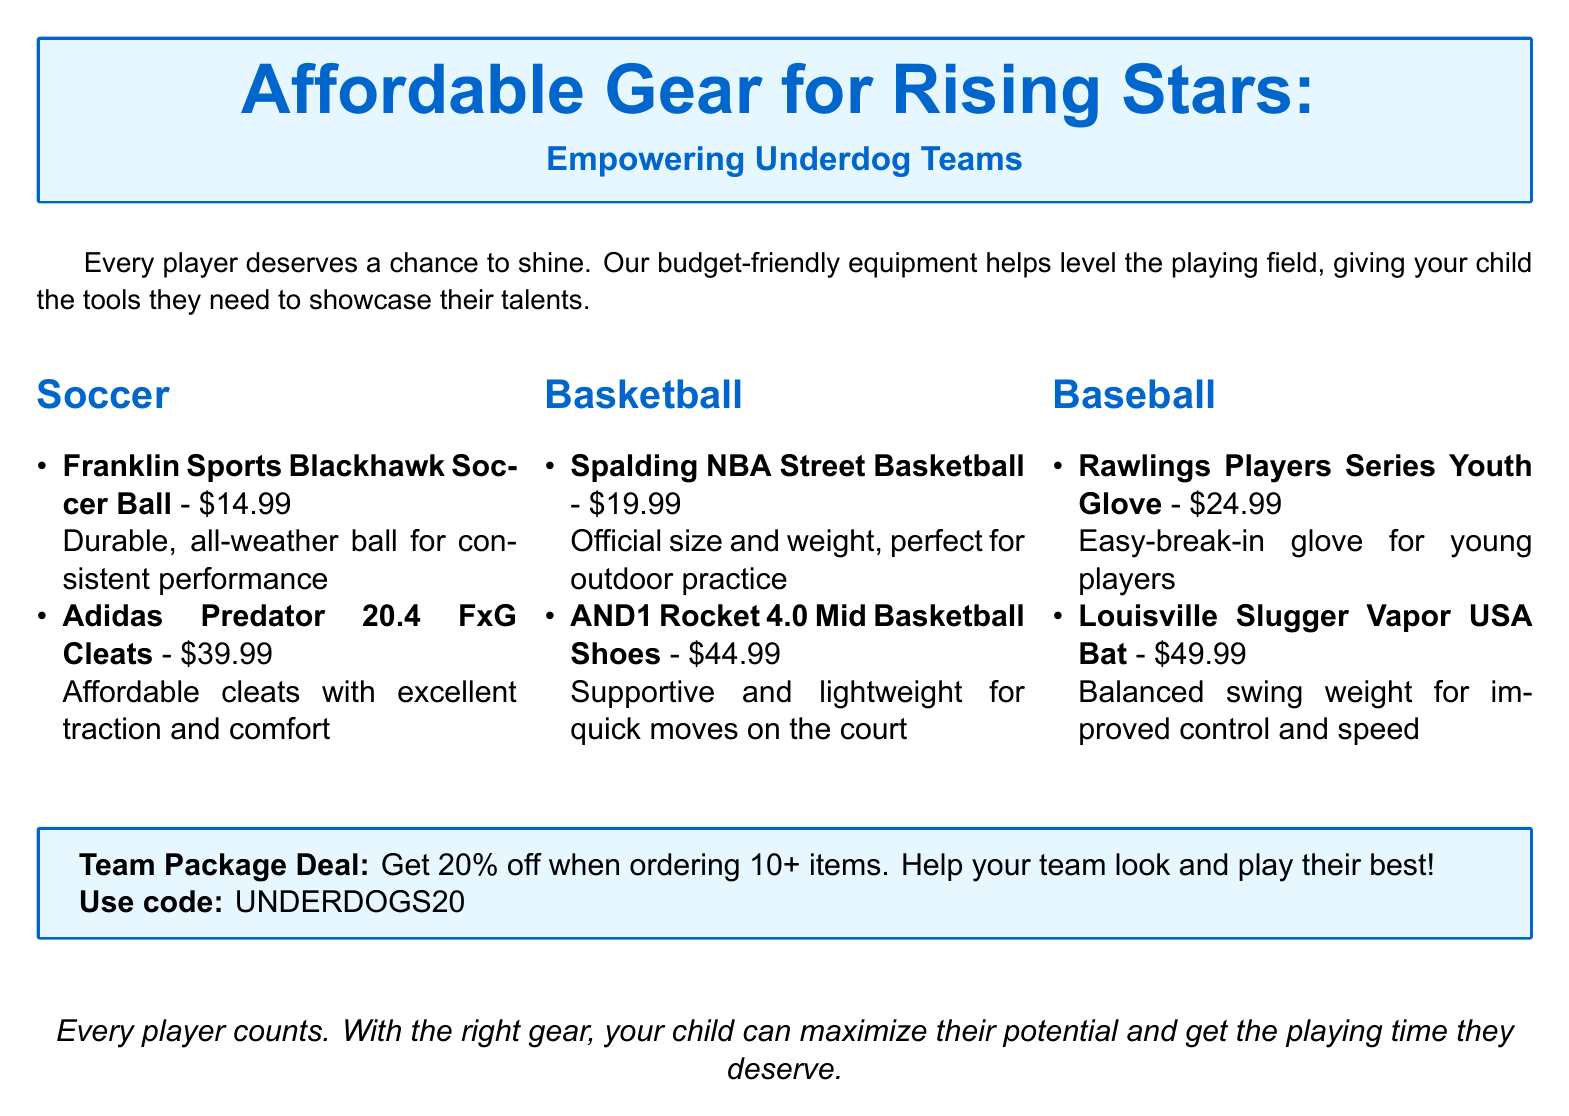What is the title of the catalog? The title of the catalog is prominently featured at the top of the document, highlighting its focus on affordable gear for underdog teams.
Answer: Affordable Gear for Rising Stars How much do the Franklin Sports Blackhawk Soccer Ball cost? The document provides pricing details of various items, and the price for this soccer ball is specifically mentioned.
Answer: $14.99 What discount is offered for team package deals? The catalog states a specific discount for team orders, which encourages bulk purchases for underdog teams.
Answer: 20% What is one feature of the Adidas Predator 20.4 FxG Cleats? The cleats have a design feature that supports performance, which is highlighted in their description provided in the document.
Answer: Excellent traction How many items need to be ordered to receive the discount code? The document specifies a minimum quantity required for the discount to apply, aimed at team purchases.
Answer: 10+ What kind of glove is the Rawlings Players Series? The document describes the glove with particular attributes suitable for young players, emphasizing its usability.
Answer: Youth glove What shoes are mentioned under basketball equipment? The catalog lists specific basketball shoes along with their pricing, highlighting equipment available for young athletes.
Answer: AND1 Rocket 4.0 Mid Basketball Shoes What is the price of the Louisville Slugger Vapor USA Bat? The document clearly mentions the price of this specific baseball bat, which is aimed at youth players.
Answer: $49.99 What is the use code for the team package deal? The catalog provides a specific code that teams can use to get a discount on their orders.
Answer: UNDERDOGS20 